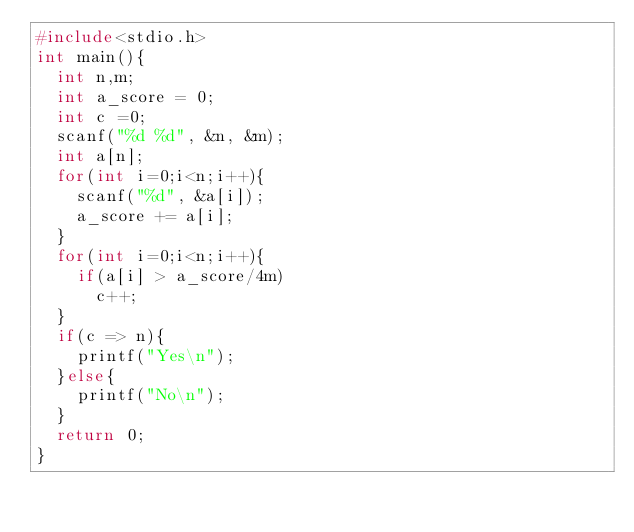<code> <loc_0><loc_0><loc_500><loc_500><_C_>#include<stdio.h>
int main(){
  int n,m;
  int a_score = 0;
  int c =0;
  scanf("%d %d", &n, &m);
  int a[n];
  for(int i=0;i<n;i++){
    scanf("%d", &a[i]);
    a_score += a[i];
  }
  for(int i=0;i<n;i++){
    if(a[i] > a_score/4m)
      c++;
  }
  if(c => n){
    printf("Yes\n");
  }else{
    printf("No\n");
  }
  return 0;
}</code> 